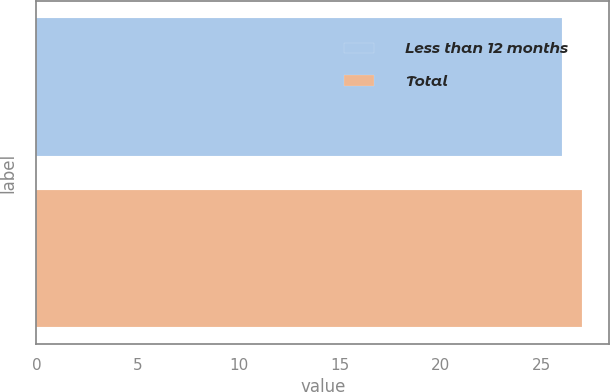<chart> <loc_0><loc_0><loc_500><loc_500><bar_chart><fcel>Less than 12 months<fcel>Total<nl><fcel>26<fcel>27<nl></chart> 